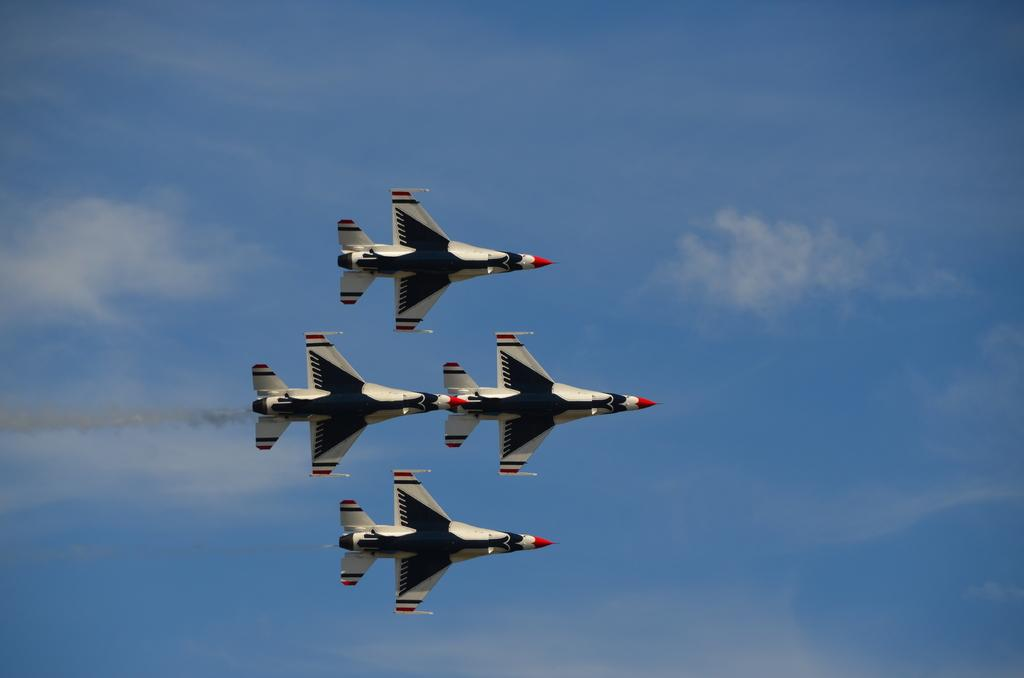What is the main subject of the image? The main subject of the image is aircrafts. What colors are the aircrafts in the image? The aircrafts are in white and black color. What can be seen in the background of the image? The sky is visible in the background of the image. What colors are present in the sky in the image? The sky is in blue and white color. How many nails can be seen holding the aircraft together in the image? There are no nails visible in the image, as aircrafts are typically held together by bolts and rivets. 